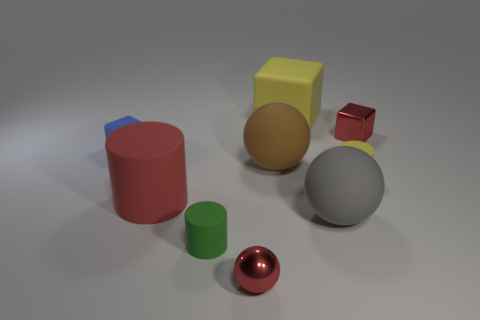Describe the relative sizes and colors of the objects present. The objects include a large brown rubber cylinder, a medium-sized yellow cube, a small blue cube with a rubber texture, a large metallic sphere, and a small red shiny sphere. The varying sizes and colors create a visually interesting assortment that exercises our spatial and color recognition abilities. Are there any objects that look soft or might be squeezable? None of the objects in the image appear soft or squeezable; they all seem to have hard surfaces, likely made from materials such as metal or hard plastic. 